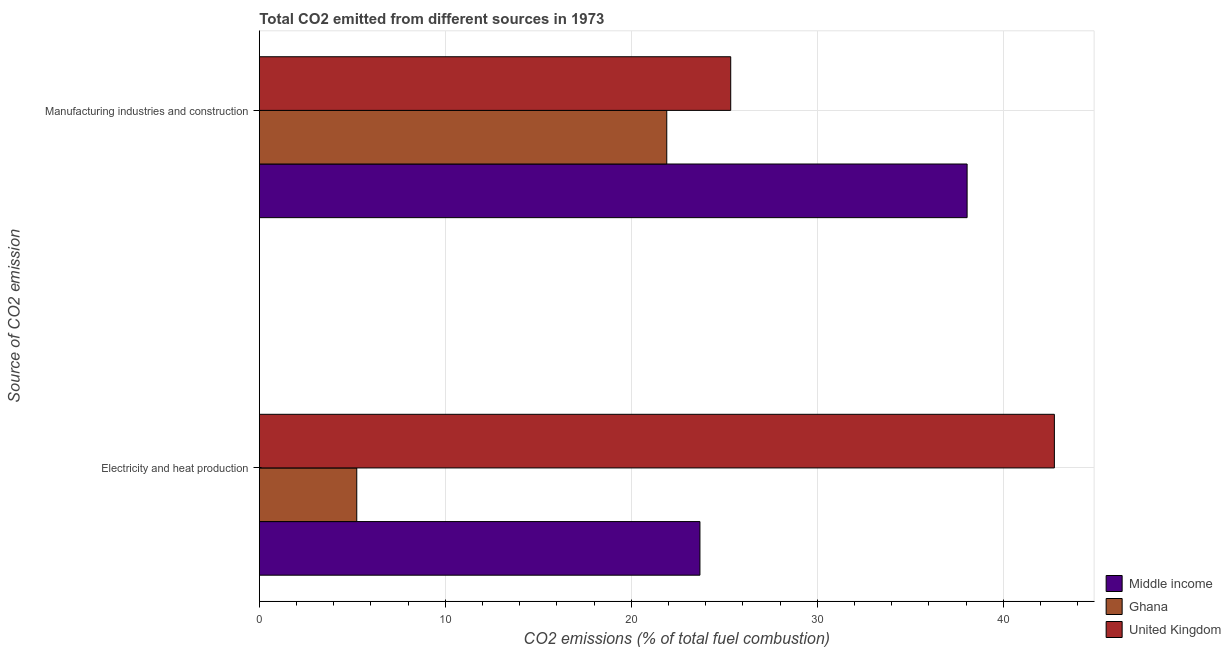How many different coloured bars are there?
Your answer should be very brief. 3. Are the number of bars on each tick of the Y-axis equal?
Offer a terse response. Yes. How many bars are there on the 2nd tick from the bottom?
Your answer should be very brief. 3. What is the label of the 1st group of bars from the top?
Provide a short and direct response. Manufacturing industries and construction. What is the co2 emissions due to manufacturing industries in United Kingdom?
Offer a very short reply. 25.34. Across all countries, what is the maximum co2 emissions due to manufacturing industries?
Offer a terse response. 38.05. Across all countries, what is the minimum co2 emissions due to manufacturing industries?
Offer a very short reply. 21.9. In which country was the co2 emissions due to manufacturing industries maximum?
Provide a short and direct response. Middle income. In which country was the co2 emissions due to manufacturing industries minimum?
Offer a very short reply. Ghana. What is the total co2 emissions due to electricity and heat production in the graph?
Your answer should be very brief. 71.67. What is the difference between the co2 emissions due to manufacturing industries in Ghana and that in Middle income?
Your answer should be compact. -16.15. What is the difference between the co2 emissions due to manufacturing industries in Middle income and the co2 emissions due to electricity and heat production in Ghana?
Your answer should be compact. 32.81. What is the average co2 emissions due to manufacturing industries per country?
Offer a terse response. 28.43. What is the difference between the co2 emissions due to electricity and heat production and co2 emissions due to manufacturing industries in Ghana?
Provide a succinct answer. -16.67. What is the ratio of the co2 emissions due to manufacturing industries in Ghana to that in Middle income?
Give a very brief answer. 0.58. Is the co2 emissions due to electricity and heat production in United Kingdom less than that in Middle income?
Your answer should be compact. No. In how many countries, is the co2 emissions due to manufacturing industries greater than the average co2 emissions due to manufacturing industries taken over all countries?
Offer a very short reply. 1. What does the 3rd bar from the top in Electricity and heat production represents?
Keep it short and to the point. Middle income. What does the 1st bar from the bottom in Manufacturing industries and construction represents?
Ensure brevity in your answer.  Middle income. Are all the bars in the graph horizontal?
Your response must be concise. Yes. What is the difference between two consecutive major ticks on the X-axis?
Offer a terse response. 10. Where does the legend appear in the graph?
Your answer should be very brief. Bottom right. What is the title of the graph?
Your answer should be compact. Total CO2 emitted from different sources in 1973. Does "Guinea-Bissau" appear as one of the legend labels in the graph?
Offer a terse response. No. What is the label or title of the X-axis?
Your answer should be very brief. CO2 emissions (% of total fuel combustion). What is the label or title of the Y-axis?
Your answer should be compact. Source of CO2 emission. What is the CO2 emissions (% of total fuel combustion) of Middle income in Electricity and heat production?
Your answer should be very brief. 23.69. What is the CO2 emissions (% of total fuel combustion) in Ghana in Electricity and heat production?
Your answer should be compact. 5.24. What is the CO2 emissions (% of total fuel combustion) of United Kingdom in Electricity and heat production?
Keep it short and to the point. 42.74. What is the CO2 emissions (% of total fuel combustion) of Middle income in Manufacturing industries and construction?
Make the answer very short. 38.05. What is the CO2 emissions (% of total fuel combustion) in Ghana in Manufacturing industries and construction?
Give a very brief answer. 21.9. What is the CO2 emissions (% of total fuel combustion) in United Kingdom in Manufacturing industries and construction?
Your answer should be very brief. 25.34. Across all Source of CO2 emission, what is the maximum CO2 emissions (% of total fuel combustion) of Middle income?
Offer a terse response. 38.05. Across all Source of CO2 emission, what is the maximum CO2 emissions (% of total fuel combustion) of Ghana?
Make the answer very short. 21.9. Across all Source of CO2 emission, what is the maximum CO2 emissions (% of total fuel combustion) of United Kingdom?
Make the answer very short. 42.74. Across all Source of CO2 emission, what is the minimum CO2 emissions (% of total fuel combustion) in Middle income?
Your response must be concise. 23.69. Across all Source of CO2 emission, what is the minimum CO2 emissions (% of total fuel combustion) in Ghana?
Your answer should be very brief. 5.24. Across all Source of CO2 emission, what is the minimum CO2 emissions (% of total fuel combustion) in United Kingdom?
Offer a terse response. 25.34. What is the total CO2 emissions (% of total fuel combustion) of Middle income in the graph?
Your answer should be compact. 61.74. What is the total CO2 emissions (% of total fuel combustion) of Ghana in the graph?
Ensure brevity in your answer.  27.14. What is the total CO2 emissions (% of total fuel combustion) of United Kingdom in the graph?
Offer a very short reply. 68.09. What is the difference between the CO2 emissions (% of total fuel combustion) of Middle income in Electricity and heat production and that in Manufacturing industries and construction?
Provide a short and direct response. -14.36. What is the difference between the CO2 emissions (% of total fuel combustion) in Ghana in Electricity and heat production and that in Manufacturing industries and construction?
Your answer should be very brief. -16.67. What is the difference between the CO2 emissions (% of total fuel combustion) of United Kingdom in Electricity and heat production and that in Manufacturing industries and construction?
Offer a terse response. 17.4. What is the difference between the CO2 emissions (% of total fuel combustion) of Middle income in Electricity and heat production and the CO2 emissions (% of total fuel combustion) of Ghana in Manufacturing industries and construction?
Your answer should be very brief. 1.78. What is the difference between the CO2 emissions (% of total fuel combustion) in Middle income in Electricity and heat production and the CO2 emissions (% of total fuel combustion) in United Kingdom in Manufacturing industries and construction?
Ensure brevity in your answer.  -1.65. What is the difference between the CO2 emissions (% of total fuel combustion) of Ghana in Electricity and heat production and the CO2 emissions (% of total fuel combustion) of United Kingdom in Manufacturing industries and construction?
Provide a short and direct response. -20.11. What is the average CO2 emissions (% of total fuel combustion) of Middle income per Source of CO2 emission?
Your answer should be very brief. 30.87. What is the average CO2 emissions (% of total fuel combustion) of Ghana per Source of CO2 emission?
Ensure brevity in your answer.  13.57. What is the average CO2 emissions (% of total fuel combustion) of United Kingdom per Source of CO2 emission?
Offer a very short reply. 34.04. What is the difference between the CO2 emissions (% of total fuel combustion) in Middle income and CO2 emissions (% of total fuel combustion) in Ghana in Electricity and heat production?
Your response must be concise. 18.45. What is the difference between the CO2 emissions (% of total fuel combustion) in Middle income and CO2 emissions (% of total fuel combustion) in United Kingdom in Electricity and heat production?
Keep it short and to the point. -19.06. What is the difference between the CO2 emissions (% of total fuel combustion) in Ghana and CO2 emissions (% of total fuel combustion) in United Kingdom in Electricity and heat production?
Your answer should be compact. -37.51. What is the difference between the CO2 emissions (% of total fuel combustion) in Middle income and CO2 emissions (% of total fuel combustion) in Ghana in Manufacturing industries and construction?
Your response must be concise. 16.15. What is the difference between the CO2 emissions (% of total fuel combustion) in Middle income and CO2 emissions (% of total fuel combustion) in United Kingdom in Manufacturing industries and construction?
Your answer should be compact. 12.71. What is the difference between the CO2 emissions (% of total fuel combustion) of Ghana and CO2 emissions (% of total fuel combustion) of United Kingdom in Manufacturing industries and construction?
Make the answer very short. -3.44. What is the ratio of the CO2 emissions (% of total fuel combustion) in Middle income in Electricity and heat production to that in Manufacturing industries and construction?
Offer a terse response. 0.62. What is the ratio of the CO2 emissions (% of total fuel combustion) in Ghana in Electricity and heat production to that in Manufacturing industries and construction?
Ensure brevity in your answer.  0.24. What is the ratio of the CO2 emissions (% of total fuel combustion) of United Kingdom in Electricity and heat production to that in Manufacturing industries and construction?
Your answer should be very brief. 1.69. What is the difference between the highest and the second highest CO2 emissions (% of total fuel combustion) in Middle income?
Your answer should be very brief. 14.36. What is the difference between the highest and the second highest CO2 emissions (% of total fuel combustion) of Ghana?
Offer a very short reply. 16.67. What is the difference between the highest and the second highest CO2 emissions (% of total fuel combustion) of United Kingdom?
Your answer should be compact. 17.4. What is the difference between the highest and the lowest CO2 emissions (% of total fuel combustion) of Middle income?
Ensure brevity in your answer.  14.36. What is the difference between the highest and the lowest CO2 emissions (% of total fuel combustion) in Ghana?
Ensure brevity in your answer.  16.67. What is the difference between the highest and the lowest CO2 emissions (% of total fuel combustion) in United Kingdom?
Your answer should be compact. 17.4. 